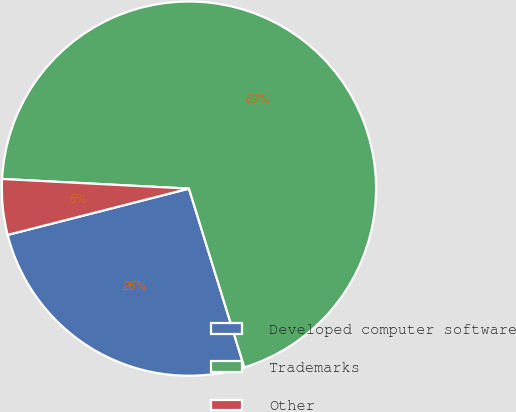<chart> <loc_0><loc_0><loc_500><loc_500><pie_chart><fcel>Developed computer software<fcel>Trademarks<fcel>Other<nl><fcel>25.8%<fcel>69.39%<fcel>4.8%<nl></chart> 